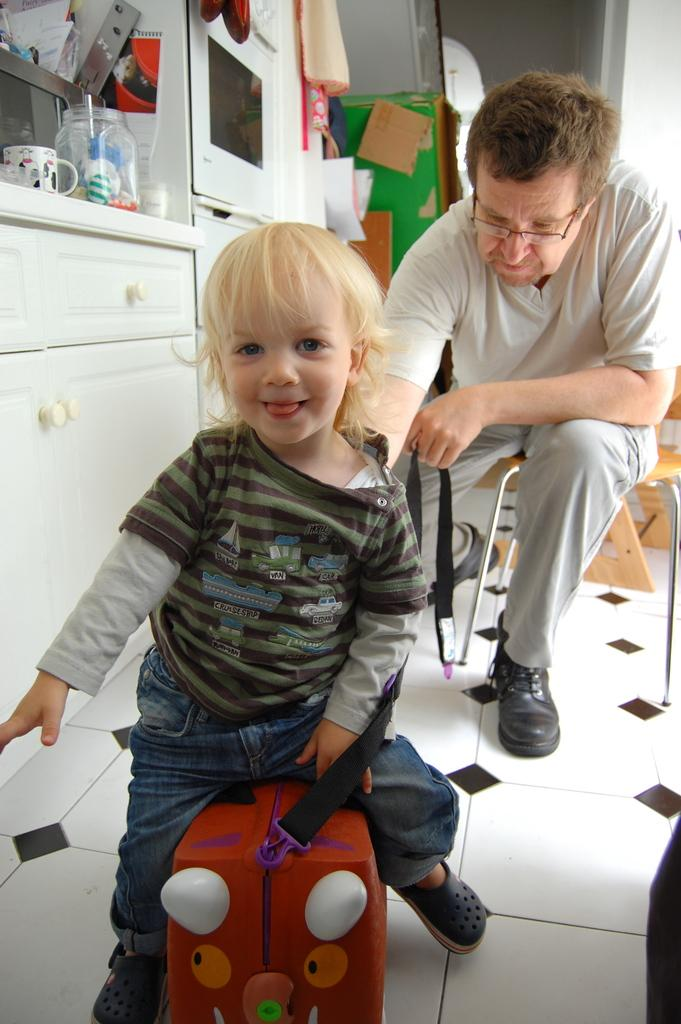What is the kid doing in the image? The kid is sitting on a suitcase. What is the man doing in the image? The man is sitting on a chair. What type of objects can be seen in the image? There is furniture, a jar, a cup, and an oven in the image. Where are the jar and cup located in the image? The jar and cup are on the furniture in the image. What type of drink is the man suggesting to the kid in the image? There is no indication in the image that the man is suggesting a drink to the kid. 